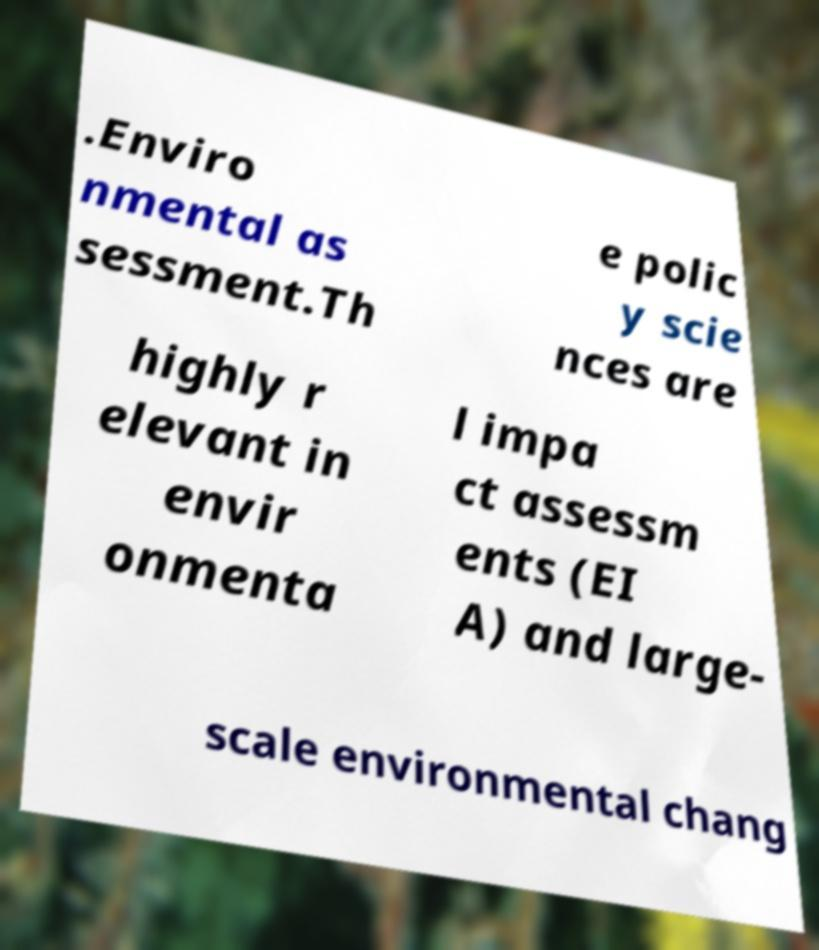I need the written content from this picture converted into text. Can you do that? .Enviro nmental as sessment.Th e polic y scie nces are highly r elevant in envir onmenta l impa ct assessm ents (EI A) and large- scale environmental chang 